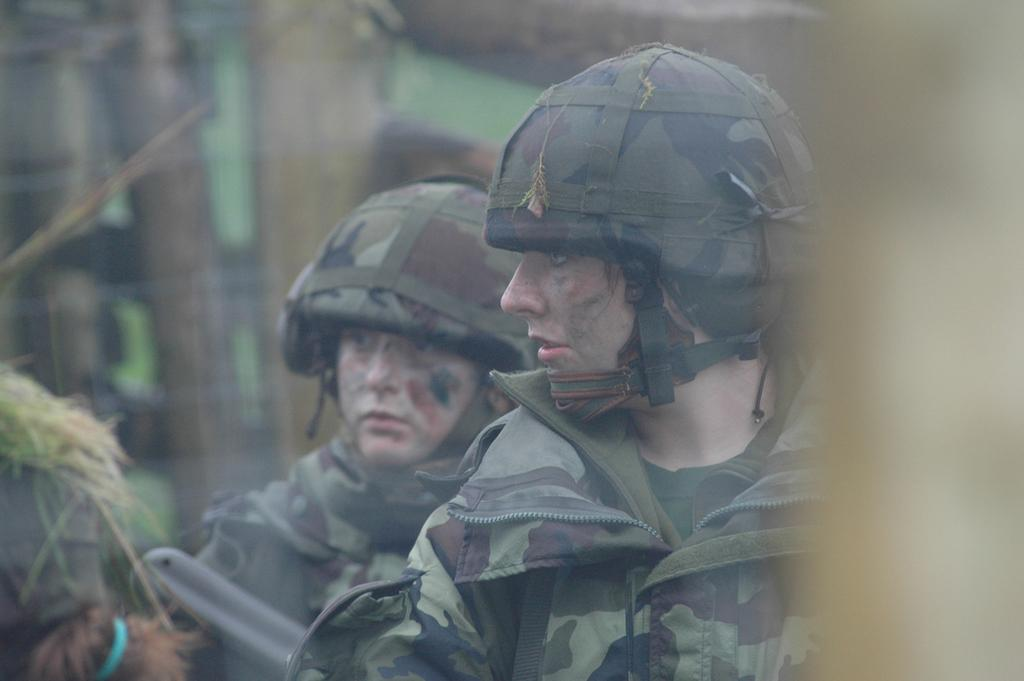How many people are in the image? There are persons standing in the image. What type of skin is visible on the roll in the image? There is no roll or skin present in the image; it only features persons standing. 